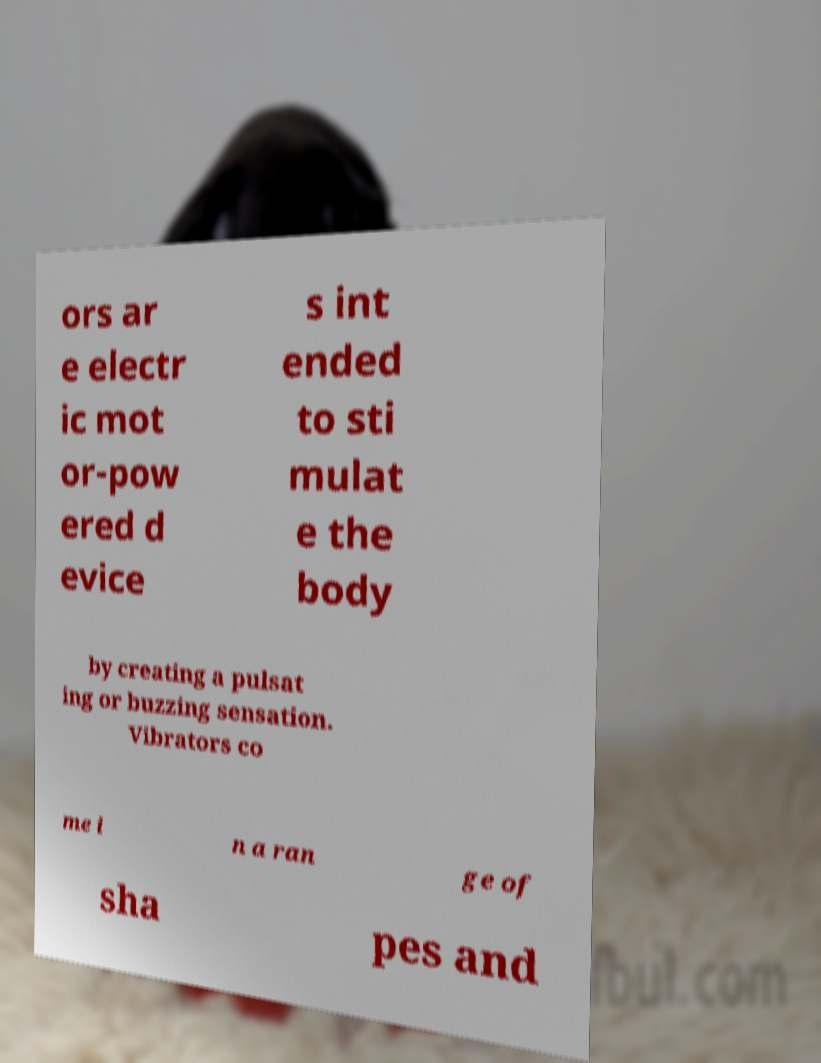I need the written content from this picture converted into text. Can you do that? ors ar e electr ic mot or-pow ered d evice s int ended to sti mulat e the body by creating a pulsat ing or buzzing sensation. Vibrators co me i n a ran ge of sha pes and 